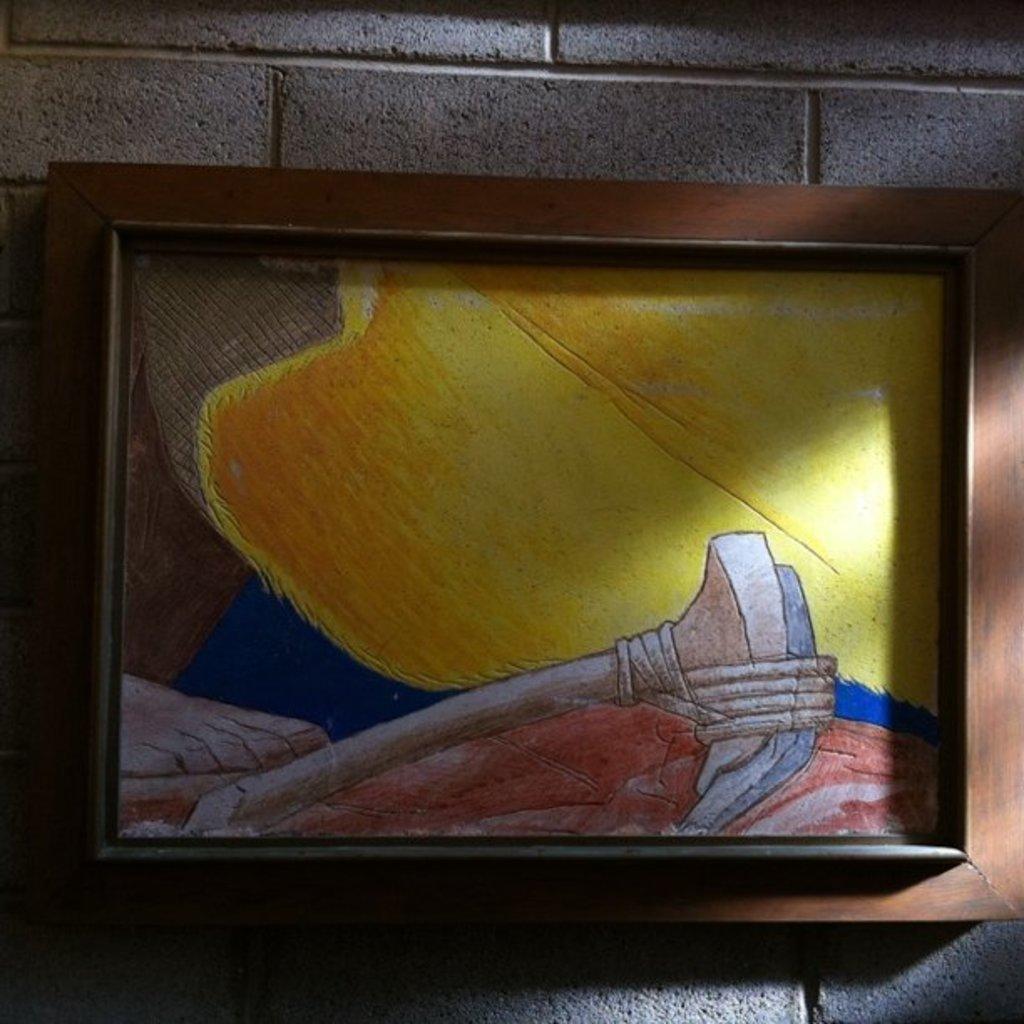Can you describe this image briefly? In this picture we can see the colorful drawing photo frame hanging on the brick wall. 